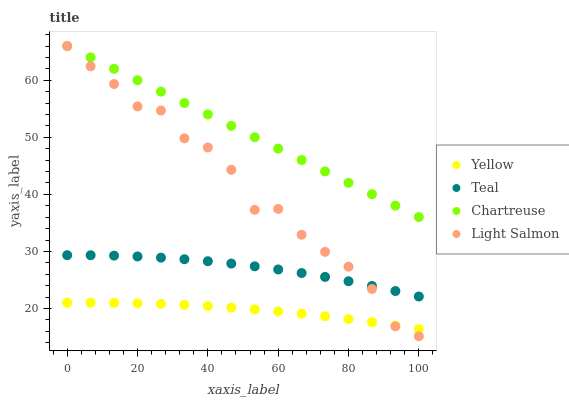Does Yellow have the minimum area under the curve?
Answer yes or no. Yes. Does Chartreuse have the maximum area under the curve?
Answer yes or no. Yes. Does Teal have the minimum area under the curve?
Answer yes or no. No. Does Teal have the maximum area under the curve?
Answer yes or no. No. Is Chartreuse the smoothest?
Answer yes or no. Yes. Is Light Salmon the roughest?
Answer yes or no. Yes. Is Teal the smoothest?
Answer yes or no. No. Is Teal the roughest?
Answer yes or no. No. Does Light Salmon have the lowest value?
Answer yes or no. Yes. Does Teal have the lowest value?
Answer yes or no. No. Does Light Salmon have the highest value?
Answer yes or no. Yes. Does Teal have the highest value?
Answer yes or no. No. Is Yellow less than Chartreuse?
Answer yes or no. Yes. Is Chartreuse greater than Yellow?
Answer yes or no. Yes. Does Light Salmon intersect Teal?
Answer yes or no. Yes. Is Light Salmon less than Teal?
Answer yes or no. No. Is Light Salmon greater than Teal?
Answer yes or no. No. Does Yellow intersect Chartreuse?
Answer yes or no. No. 